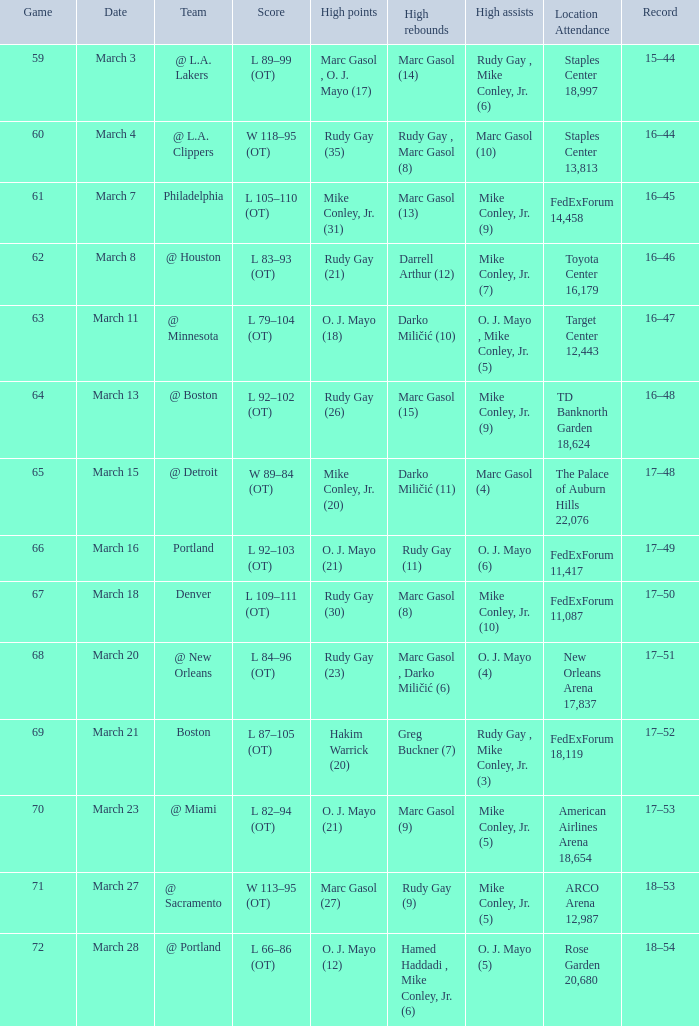Who recorded the most assists on march 18? Mike Conley, Jr. (10). 